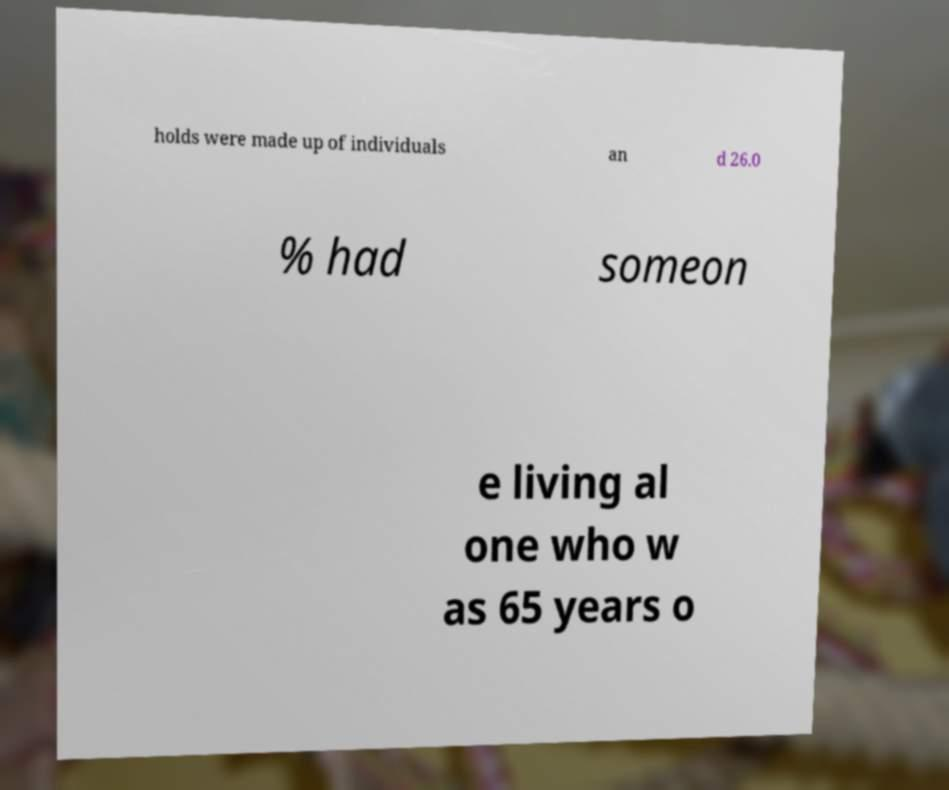For documentation purposes, I need the text within this image transcribed. Could you provide that? holds were made up of individuals an d 26.0 % had someon e living al one who w as 65 years o 